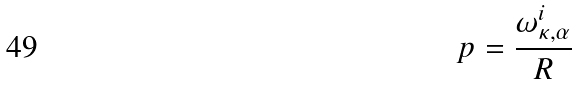Convert formula to latex. <formula><loc_0><loc_0><loc_500><loc_500>p = \frac { \omega _ { \kappa , \alpha } ^ { i } } { R }</formula> 